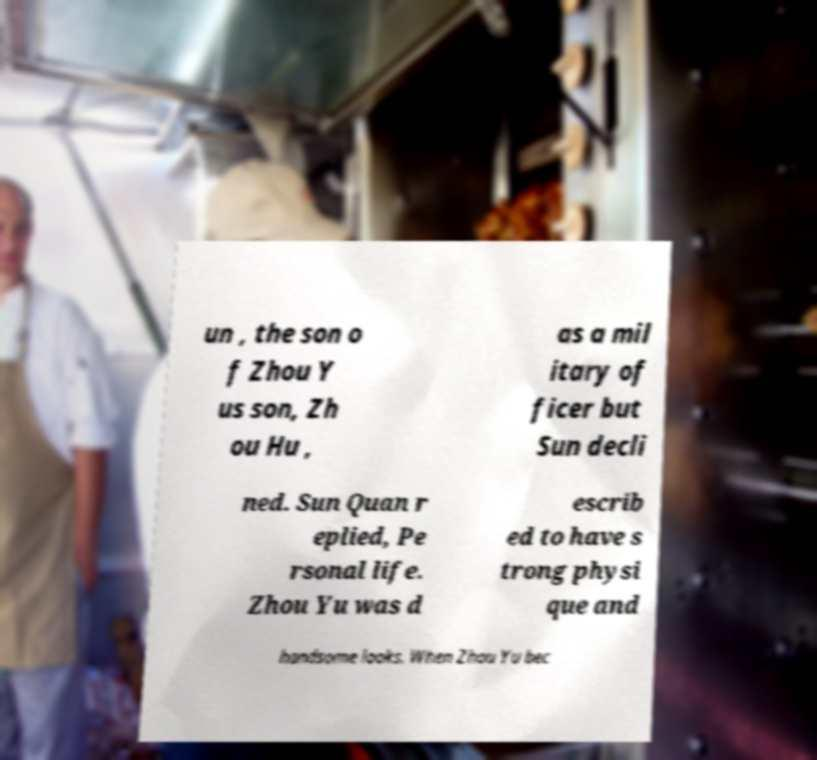There's text embedded in this image that I need extracted. Can you transcribe it verbatim? un , the son o f Zhou Y us son, Zh ou Hu , as a mil itary of ficer but Sun decli ned. Sun Quan r eplied, Pe rsonal life. Zhou Yu was d escrib ed to have s trong physi que and handsome looks. When Zhou Yu bec 